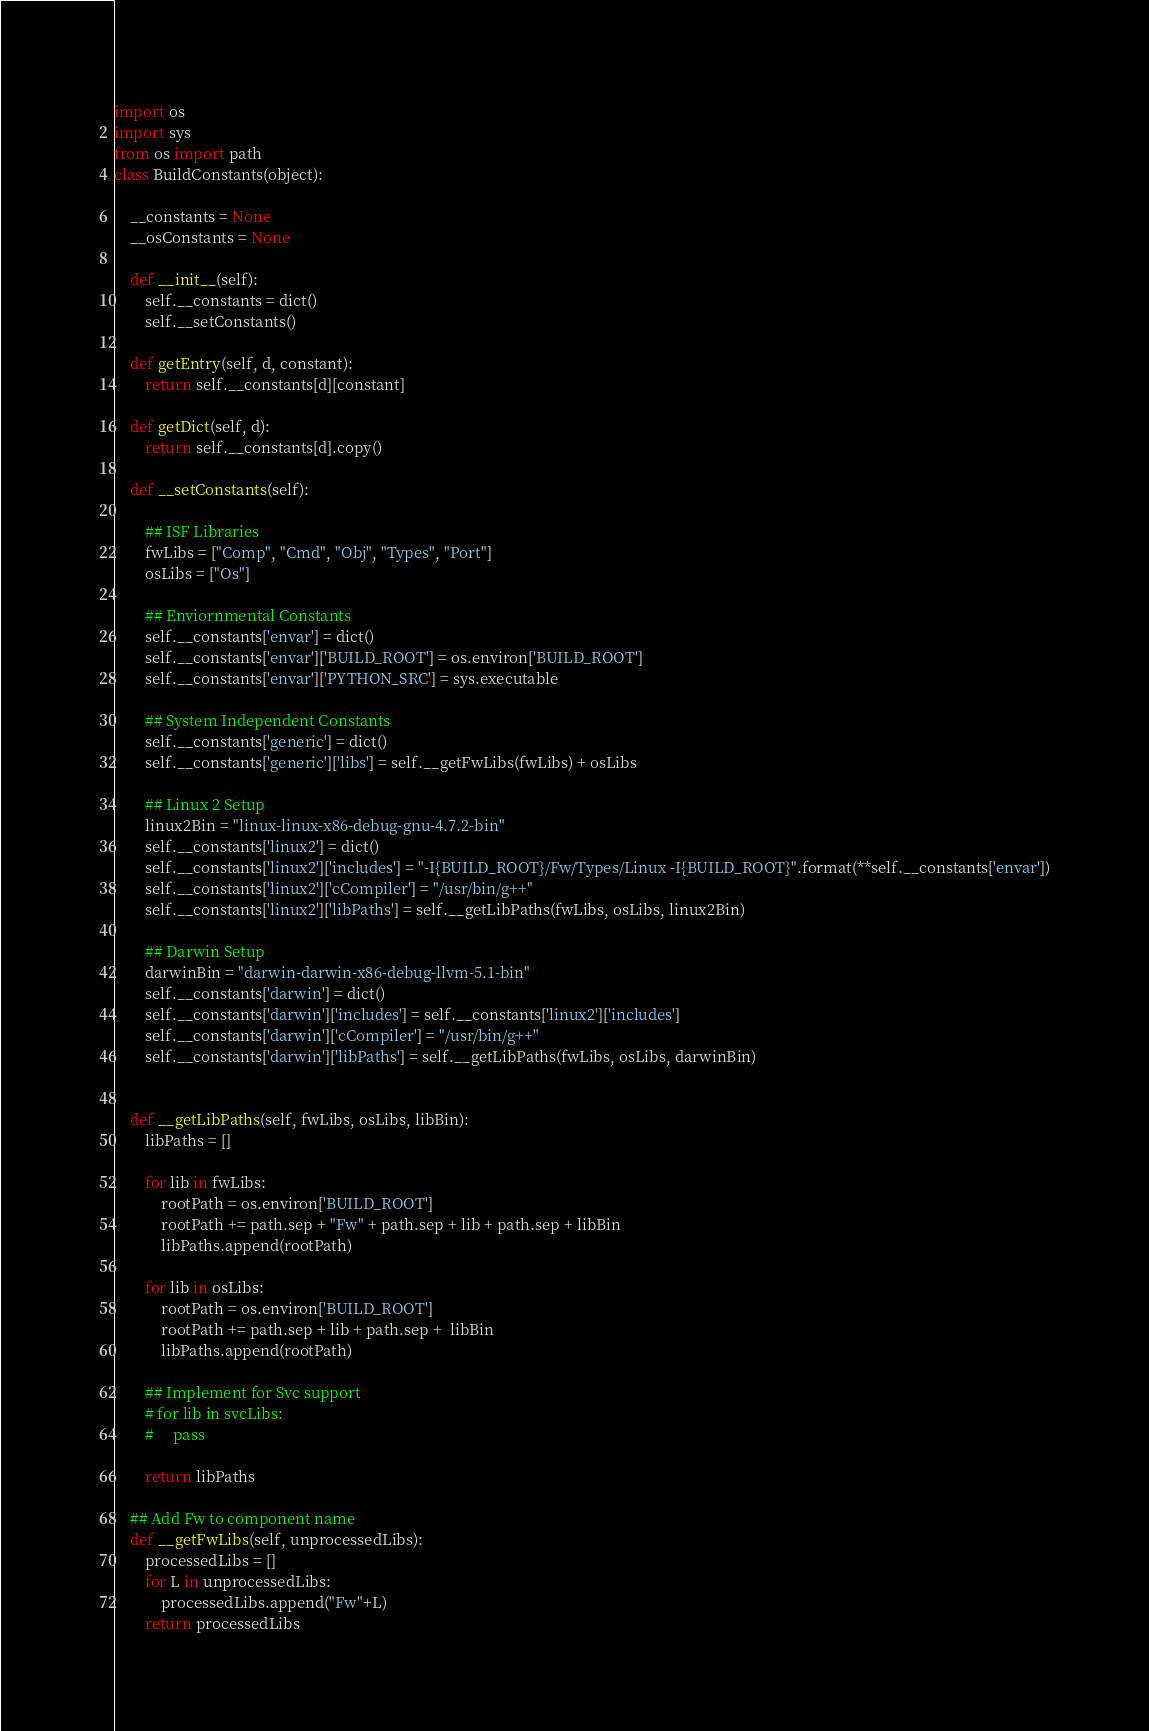Convert code to text. <code><loc_0><loc_0><loc_500><loc_500><_Python_>import os
import sys
from os import path
class BuildConstants(object):

    __constants = None
    __osConstants = None

    def __init__(self):
        self.__constants = dict()
        self.__setConstants()

    def getEntry(self, d, constant):
        return self.__constants[d][constant]

    def getDict(self, d):
        return self.__constants[d].copy()

    def __setConstants(self):

        ## ISF Libraries
        fwLibs = ["Comp", "Cmd", "Obj", "Types", "Port"]
        osLibs = ["Os"]

        ## Enviornmental Constants
        self.__constants['envar'] = dict()
        self.__constants['envar']['BUILD_ROOT'] = os.environ['BUILD_ROOT']
        self.__constants['envar']['PYTHON_SRC'] = sys.executable

        ## System Independent Constants
        self.__constants['generic'] = dict()
        self.__constants['generic']['libs'] = self.__getFwLibs(fwLibs) + osLibs

        ## Linux 2 Setup
        linux2Bin = "linux-linux-x86-debug-gnu-4.7.2-bin"
        self.__constants['linux2'] = dict()
        self.__constants['linux2']['includes'] = "-I{BUILD_ROOT}/Fw/Types/Linux -I{BUILD_ROOT}".format(**self.__constants['envar'])
        self.__constants['linux2']['cCompiler'] = "/usr/bin/g++"
        self.__constants['linux2']['libPaths'] = self.__getLibPaths(fwLibs, osLibs, linux2Bin)

        ## Darwin Setup
        darwinBin = "darwin-darwin-x86-debug-llvm-5.1-bin"
        self.__constants['darwin'] = dict()
        self.__constants['darwin']['includes'] = self.__constants['linux2']['includes']
        self.__constants['darwin']['cCompiler'] = "/usr/bin/g++"
        self.__constants['darwin']['libPaths'] = self.__getLibPaths(fwLibs, osLibs, darwinBin)


    def __getLibPaths(self, fwLibs, osLibs, libBin):
        libPaths = []

        for lib in fwLibs:
            rootPath = os.environ['BUILD_ROOT']
            rootPath += path.sep + "Fw" + path.sep + lib + path.sep + libBin
            libPaths.append(rootPath)

        for lib in osLibs:
            rootPath = os.environ['BUILD_ROOT']
            rootPath += path.sep + lib + path.sep +  libBin
            libPaths.append(rootPath)

        ## Implement for Svc support
        # for lib in svcLibs:
        #     pass

        return libPaths

    ## Add Fw to component name
    def __getFwLibs(self, unprocessedLibs):
        processedLibs = []
        for L in unprocessedLibs:
            processedLibs.append("Fw"+L)
        return processedLibs

</code> 